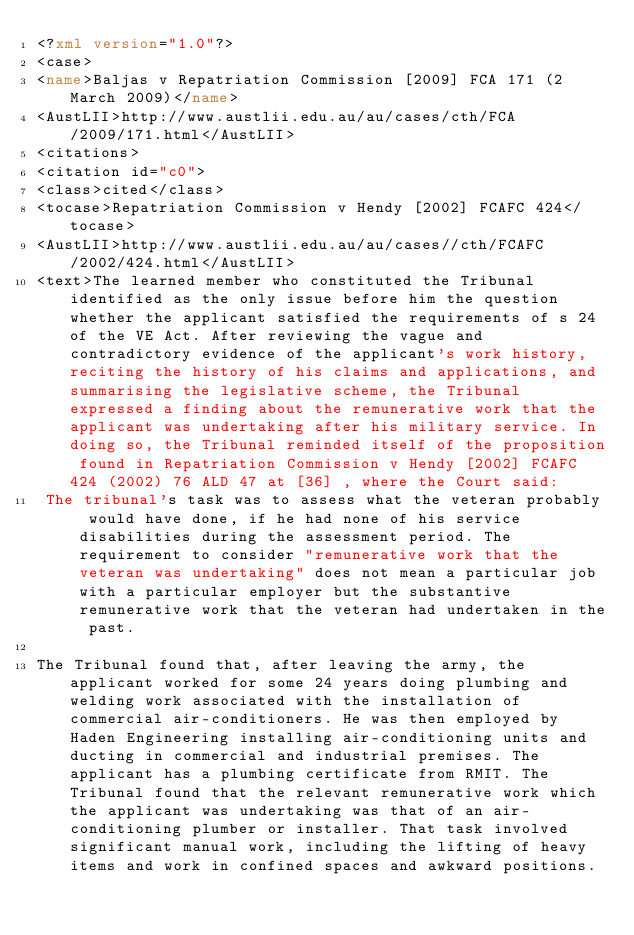<code> <loc_0><loc_0><loc_500><loc_500><_XML_><?xml version="1.0"?>
<case>
<name>Baljas v Repatriation Commission [2009] FCA 171 (2 March 2009)</name>
<AustLII>http://www.austlii.edu.au/au/cases/cth/FCA/2009/171.html</AustLII>
<citations>
<citation id="c0">
<class>cited</class>
<tocase>Repatriation Commission v Hendy [2002] FCAFC 424</tocase>
<AustLII>http://www.austlii.edu.au/au/cases//cth/FCAFC/2002/424.html</AustLII>
<text>The learned member who constituted the Tribunal identified as the only issue before him the question whether the applicant satisfied the requirements of s 24 of the VE Act. After reviewing the vague and contradictory evidence of the applicant's work history, reciting the history of his claims and applications, and summarising the legislative scheme, the Tribunal expressed a finding about the remunerative work that the applicant was undertaking after his military service. In doing so, the Tribunal reminded itself of the proposition found in Repatriation Commission v Hendy [2002] FCAFC 424 (2002) 76 ALD 47 at [36] , where the Court said: 
 The tribunal's task was to assess what the veteran probably would have done, if he had none of his service disabilities during the assessment period. The requirement to consider "remunerative work that the veteran was undertaking" does not mean a particular job with a particular employer but the substantive remunerative work that the veteran had undertaken in the past.

The Tribunal found that, after leaving the army, the applicant worked for some 24 years doing plumbing and welding work associated with the installation of commercial air-conditioners. He was then employed by Haden Engineering installing air-conditioning units and ducting in commercial and industrial premises. The applicant has a plumbing certificate from RMIT. The Tribunal found that the relevant remunerative work which the applicant was undertaking was that of an air-conditioning plumber or installer. That task involved significant manual work, including the lifting of heavy items and work in confined spaces and awkward positions.
</code> 